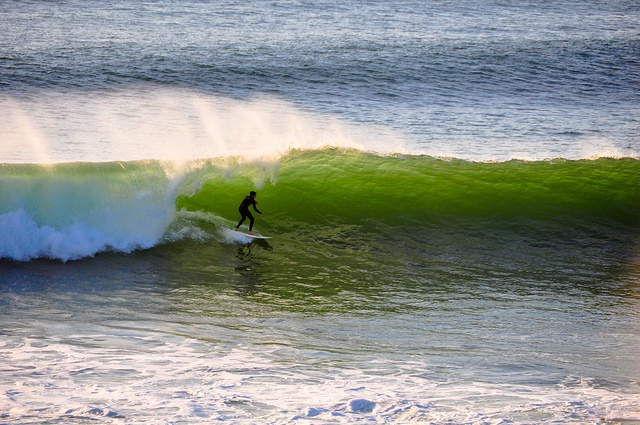Describe the objects in this image and their specific colors. I can see people in gray, black, and darkgreen tones and surfboard in gray, darkgray, black, and lightblue tones in this image. 